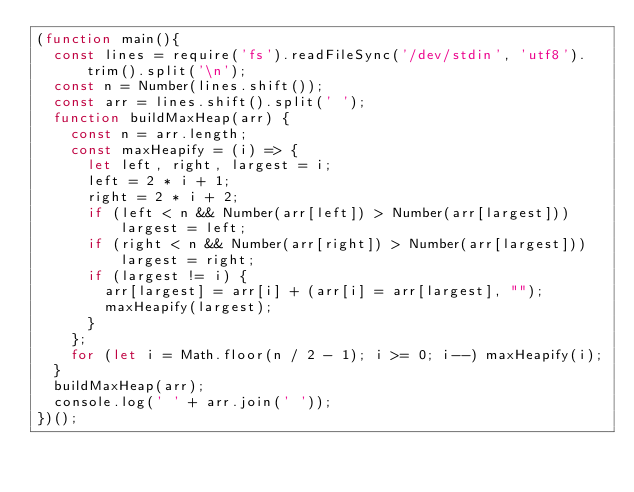Convert code to text. <code><loc_0><loc_0><loc_500><loc_500><_JavaScript_>(function main(){
  const lines = require('fs').readFileSync('/dev/stdin', 'utf8').trim().split('\n');
  const n = Number(lines.shift());
  const arr = lines.shift().split(' ');
  function buildMaxHeap(arr) {
    const n = arr.length;
    const maxHeapify = (i) => {
      let left, right, largest = i;
      left = 2 * i + 1;
      right = 2 * i + 2;
      if (left < n && Number(arr[left]) > Number(arr[largest])) largest = left;
      if (right < n && Number(arr[right]) > Number(arr[largest])) largest = right;
      if (largest != i) {
        arr[largest] = arr[i] + (arr[i] = arr[largest], "");
        maxHeapify(largest);
      }
    };
    for (let i = Math.floor(n / 2 - 1); i >= 0; i--) maxHeapify(i);
  }
  buildMaxHeap(arr);
  console.log(' ' + arr.join(' '));
})();

</code> 